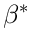Convert formula to latex. <formula><loc_0><loc_0><loc_500><loc_500>\beta ^ { * }</formula> 